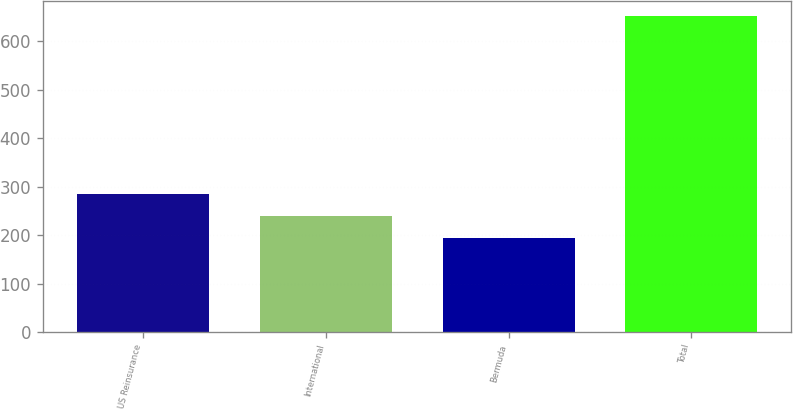Convert chart to OTSL. <chart><loc_0><loc_0><loc_500><loc_500><bar_chart><fcel>US Reinsurance<fcel>International<fcel>Bermuda<fcel>Total<nl><fcel>285.52<fcel>239.76<fcel>194<fcel>651.6<nl></chart> 